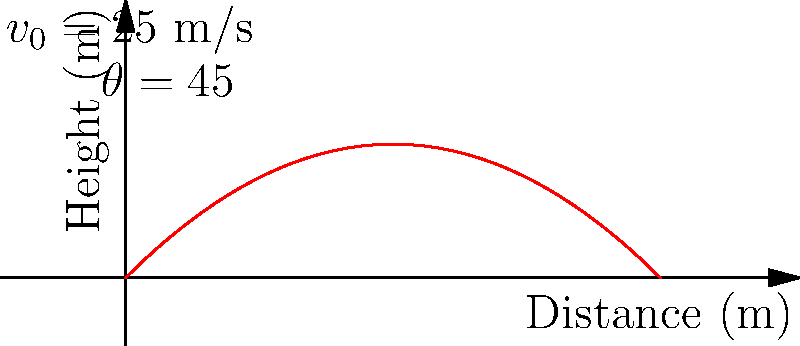As the head coach of the Arizona Cardinals, you're analyzing punt strategies. A punter kicks the ball with an initial velocity of 25 m/s at a 45-degree angle. Neglecting air resistance, calculate:

a) The maximum height reached by the ball
b) The total distance traveled by the ball

How could this information be used to improve the team's punting strategy? Let's break this down step-by-step:

1) First, we need to recall some key equations:
   - Vertical motion: $y = v_0 \sin(\theta) t - \frac{1}{2}gt^2$
   - Horizontal motion: $x = v_0 \cos(\theta) t$
   - Time to reach maximum height: $t_{max} = \frac{v_0 \sin(\theta)}{g}$

2) Given:
   - Initial velocity, $v_0 = 25$ m/s
   - Angle, $\theta = 45°$
   - Acceleration due to gravity, $g = 9.8$ m/s²

3) To find the maximum height:
   a) Calculate time to reach maximum height:
      $t_{max} = \frac{25 \sin(45°)}{9.8} = 1.80$ s
   b) Use the vertical motion equation:
      $y_{max} = 25 \sin(45°)(1.80) - \frac{1}{2}(9.8)(1.80)^2$
      $y_{max} = 31.82 - 15.91 = 15.91$ m

4) To find the total distance:
   a) Calculate total time of flight:
      $t_{total} = 2t_{max} = 2(1.80) = 3.60$ s
   b) Use the horizontal motion equation:
      $x_{total} = 25 \cos(45°)(3.60) = 63.64$ m

5) Improving punting strategy:
   - Understanding the relationship between initial velocity, angle, and punt distance can help optimize kick performance.
   - Adjusting the angle slightly below 45° might increase distance while maintaining sufficient height to avoid blocks.
   - Considering factors like wind and opponent's return capabilities when choosing punt trajectory.
Answer: a) Maximum height: 15.91 m
b) Total distance: 63.64 m 